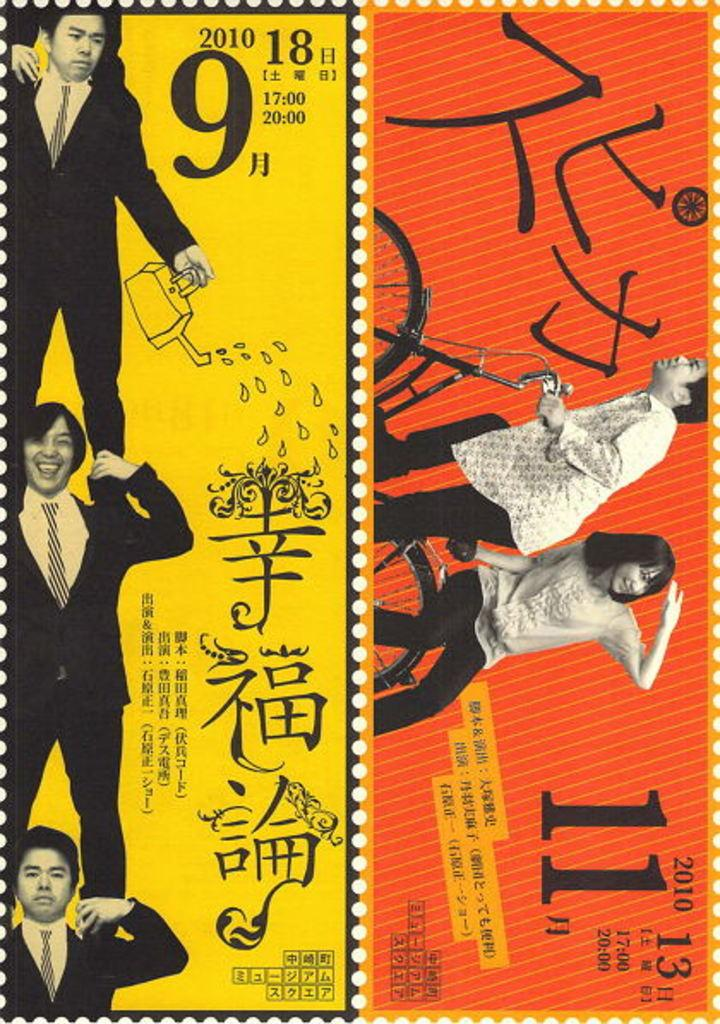<image>
Create a compact narrative representing the image presented. Asian writing and pictures on some type of sign. 